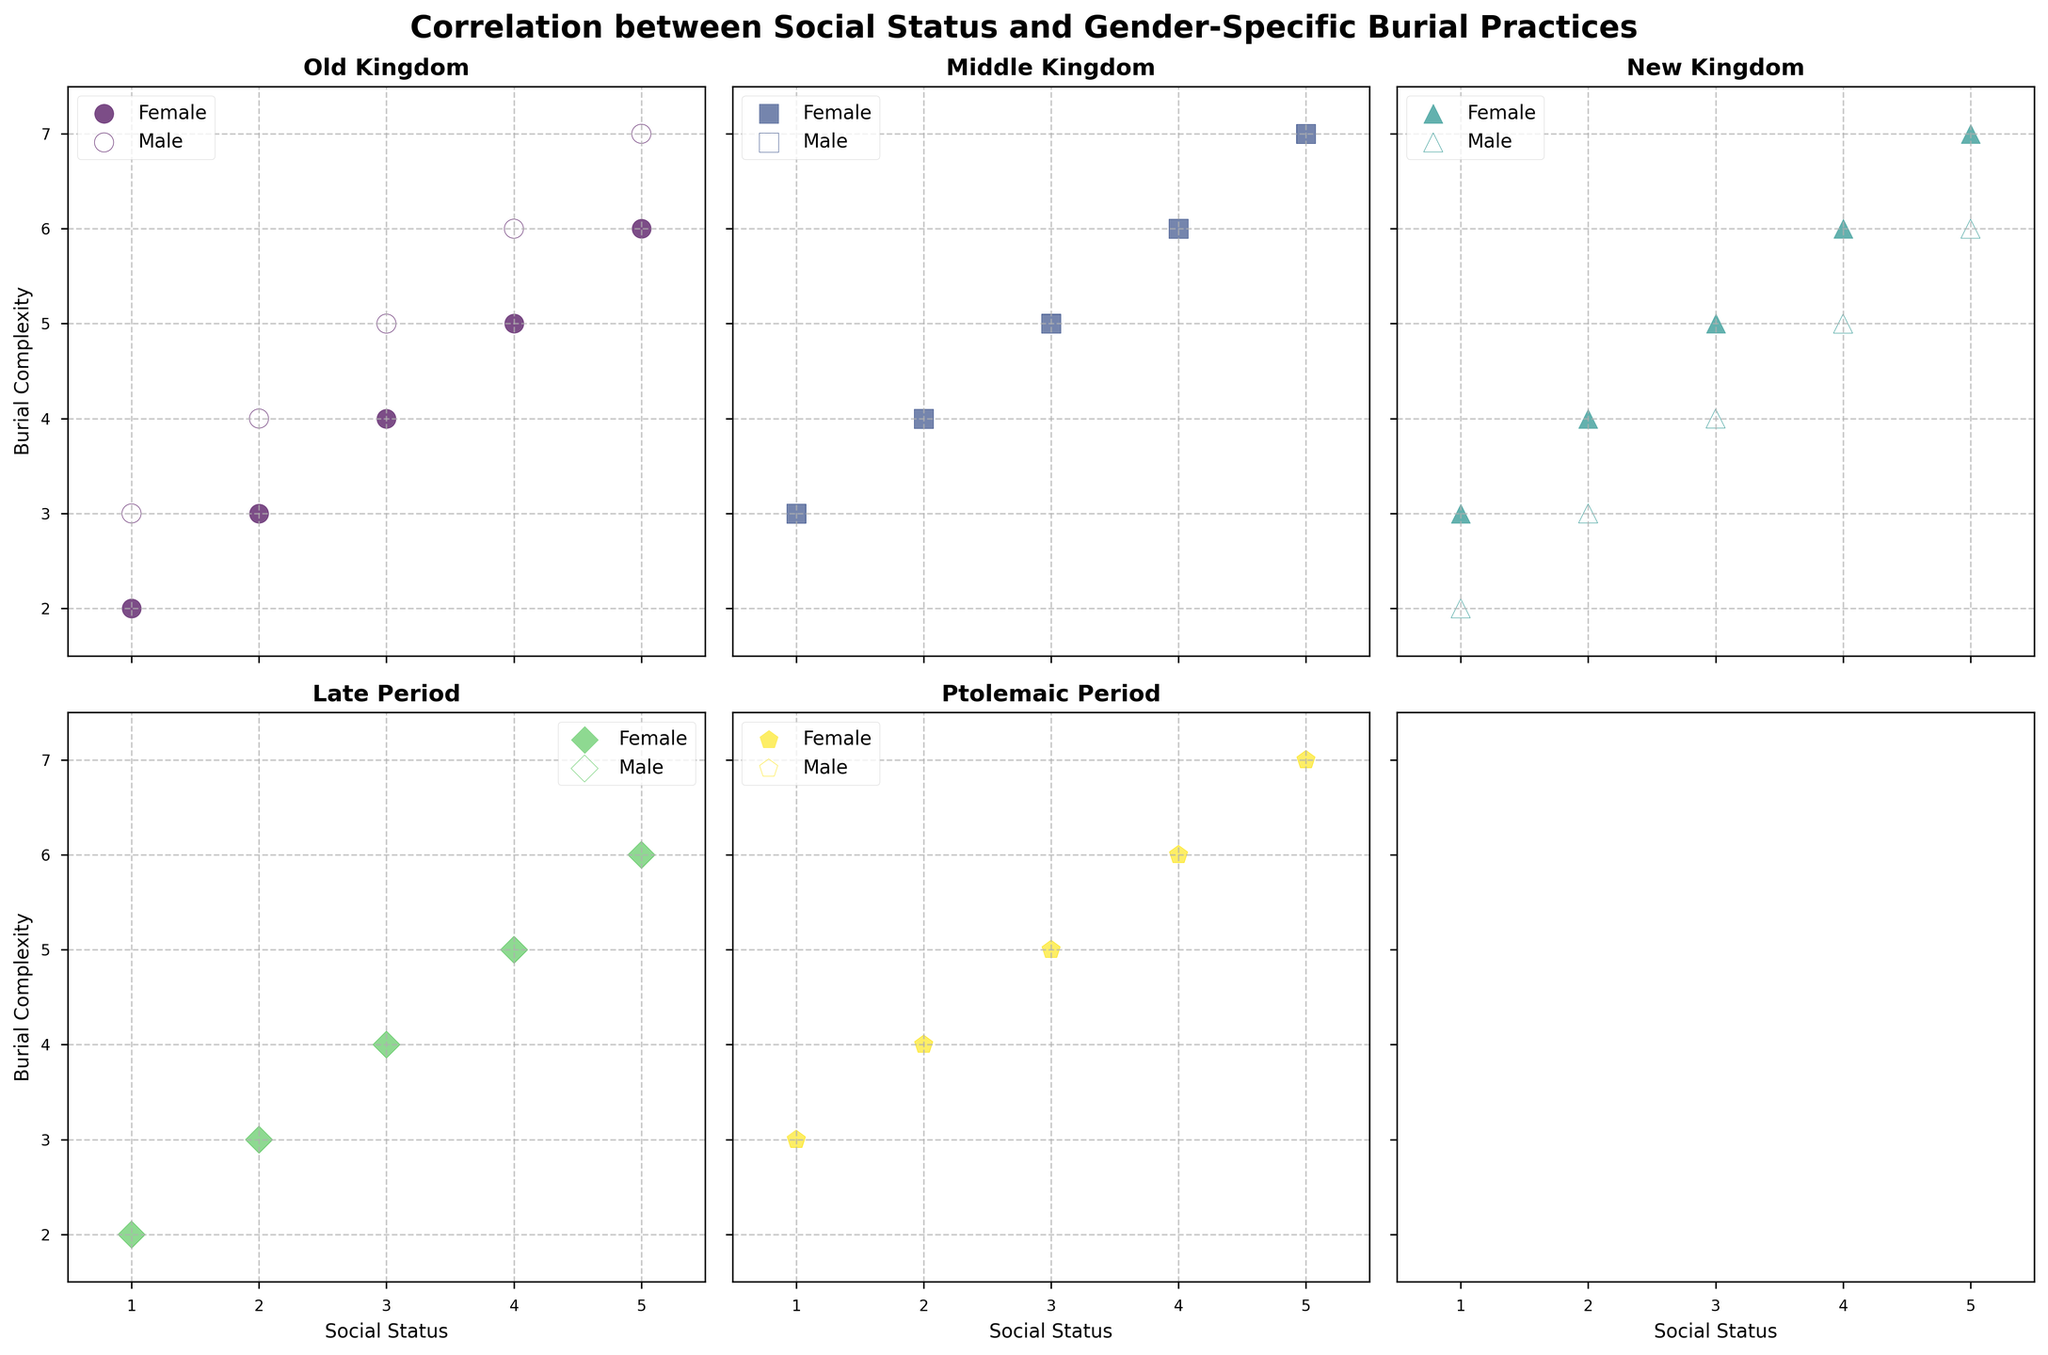What is the relationship between social status and female burial complexity in the Old Kingdom? In the Old Kingdom subplot, as social status increases from 1 to 5, the female burial complexity also increases from 2 to 6. This indicates a positive correlation between social status and female burial complexity in the Old Kingdom.
Answer: Positive correlation How does male burial complexity in the New Kingdom compare to female burial complexity when social status is 2? In the New Kingdom subplot, at social status 2, the male burial complexity is plotted as an empty marker and has a value of 3, while the female burial complexity has a value of 4.
Answer: Male burial complexity is lower than female Which dynasty shows the least difference between male and female burial complexity across all social statuses? By comparing the subplots, the Middle Kingdom shows the least difference between male and female burial complexities across all social statuses as both complexities follow the same trend line.
Answer: Middle Kingdom If you averaged the male and female burial complexity for social status 3, which dynasty has the highest average? The averages for social status 3 are:
Old Kingdom: (4+5)/2 = 4.5
Middle Kingdom: (5+5)/2 = 5
New Kingdom: (5+4)/2 = 4.5
Late Period: (4+4)/2 = 4
Ptolemaic Period: (5+5)/2 = 5
The Middle Kingdom and Ptolemaic Period both have the highest average complexity of 5.
Answer: Middle Kingdom and Ptolemaic Period What trend do you observe in female burial complexity as social status increases in the Late Period? In the Late Period subplot, the female burial complexity increases linearly as social status increases from 1 to 5, starting from 2 and reaching up to 6.
Answer: Linear increase Is there a dynasty where male burial complexity decreases as social status increases? In the New Kingdom subplot, the male burial complexity decreases from social status 1 to social status 2 (from 2 to 3) and then continues to increase, but overall, there is no continuous decrease pattern observed.
Answer: No dynasty What is the maximum burial complexity observed for males in the Middle Kingdom? By observing the Middle Kingdom subplot, the maximum male burial complexity is plotted with an empty marker at social status 5, which is 7.
Answer: 7 Compare the variability in female burial complexity across the dynasties. Which dynasty shows the greatest variability? By examining the spread of values in the subplots, the Old Kingdom shows the greatest variability in female burial complexity, ranging from 2 to 6, compared to other dynasties.
Answer: Old Kingdom In which dynasty is the disparity between male and female burial complexities the most significant at social status 1? At social status 1:
Old Kingdom: Male 3 - Female 2 = 1
Middle Kingdom: Male 3 - Female 3 = 0
New Kingdom: Male 2 - Female 3 = -1
Late Period: Male 2 - Female 2 = 0
Ptolemaic Period: Male 3 - Female 3 = 0
The Old Kingdom shows the most significant disparity with a difference of 1.
Answer: Old Kingdom What pattern can be observed in the subplots when comparing the colored and uncolored markers? In each subplot across dynasties, colored markers (representing female burial complexity) show an increasing trend with social status, while the uncolored markers (representing male burial complexity) also generally increase but sometimes show fluctuations.
Answer: Both markers generally increase, with some fluctuations in males 